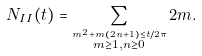Convert formula to latex. <formula><loc_0><loc_0><loc_500><loc_500>N _ { I I } ( t ) = \sum _ { \stackrel { m ^ { 2 } + m ( 2 n + 1 ) \leq t / 2 \pi } { m \geq 1 , n \geq 0 } } 2 m .</formula> 